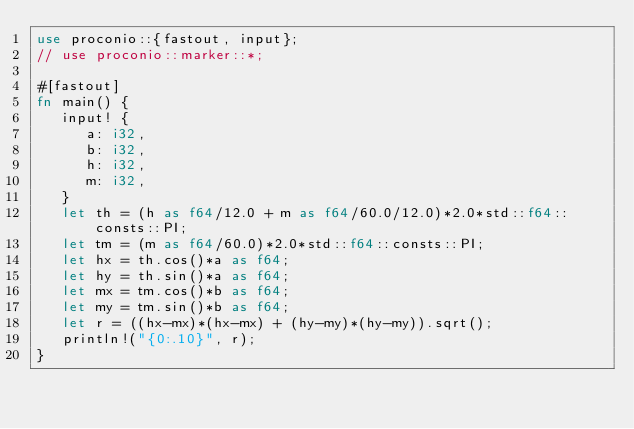Convert code to text. <code><loc_0><loc_0><loc_500><loc_500><_Rust_>use proconio::{fastout, input};
// use proconio::marker::*;

#[fastout]
fn main() {
   input! {
      a: i32,
      b: i32,
      h: i32,
      m: i32,
   }
   let th = (h as f64/12.0 + m as f64/60.0/12.0)*2.0*std::f64::consts::PI;
   let tm = (m as f64/60.0)*2.0*std::f64::consts::PI;
   let hx = th.cos()*a as f64;
   let hy = th.sin()*a as f64;
   let mx = tm.cos()*b as f64;
   let my = tm.sin()*b as f64;
   let r = ((hx-mx)*(hx-mx) + (hy-my)*(hy-my)).sqrt();
   println!("{0:.10}", r);
}
</code> 